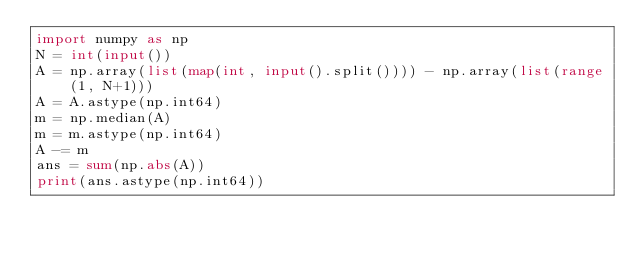<code> <loc_0><loc_0><loc_500><loc_500><_Python_>import numpy as np
N = int(input())
A = np.array(list(map(int, input().split()))) - np.array(list(range(1, N+1)))
A = A.astype(np.int64)
m = np.median(A)
m = m.astype(np.int64)
A -= m
ans = sum(np.abs(A))
print(ans.astype(np.int64))</code> 